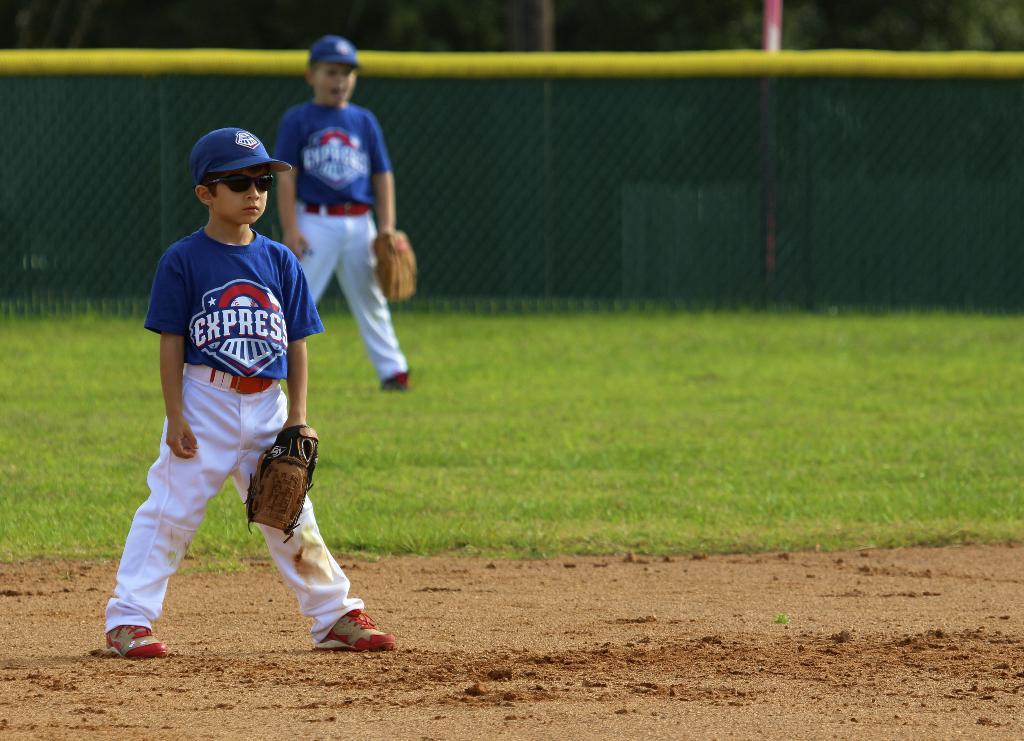What is the name of the team?
Your answer should be very brief. Express. 